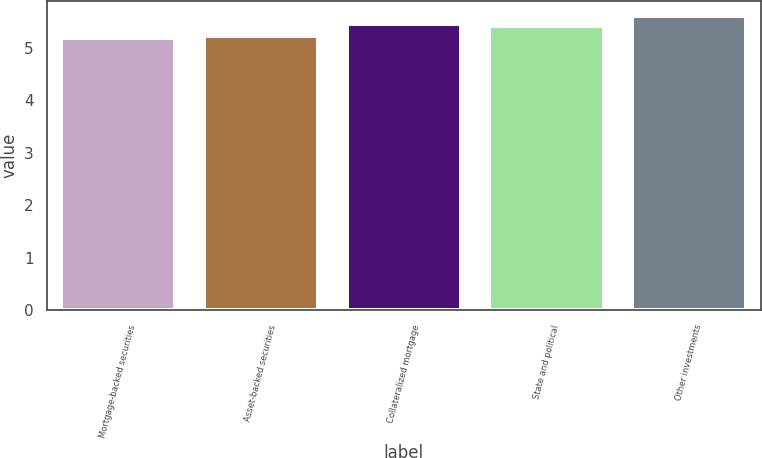Convert chart. <chart><loc_0><loc_0><loc_500><loc_500><bar_chart><fcel>Mortgage-backed securities<fcel>Asset-backed securities<fcel>Collateralized mortgage<fcel>State and political<fcel>Other investments<nl><fcel>5.18<fcel>5.22<fcel>5.45<fcel>5.41<fcel>5.61<nl></chart> 